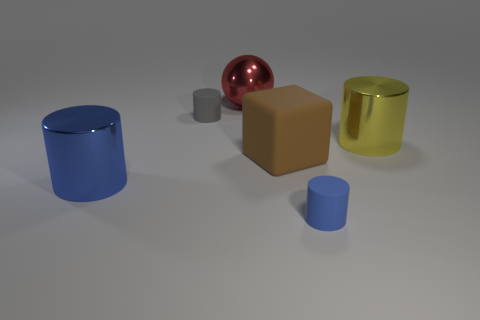Add 2 tiny gray spheres. How many objects exist? 8 Subtract all spheres. How many objects are left? 5 Subtract 0 brown spheres. How many objects are left? 6 Subtract all red matte things. Subtract all blue matte objects. How many objects are left? 5 Add 5 big red balls. How many big red balls are left? 6 Add 2 brown blocks. How many brown blocks exist? 3 